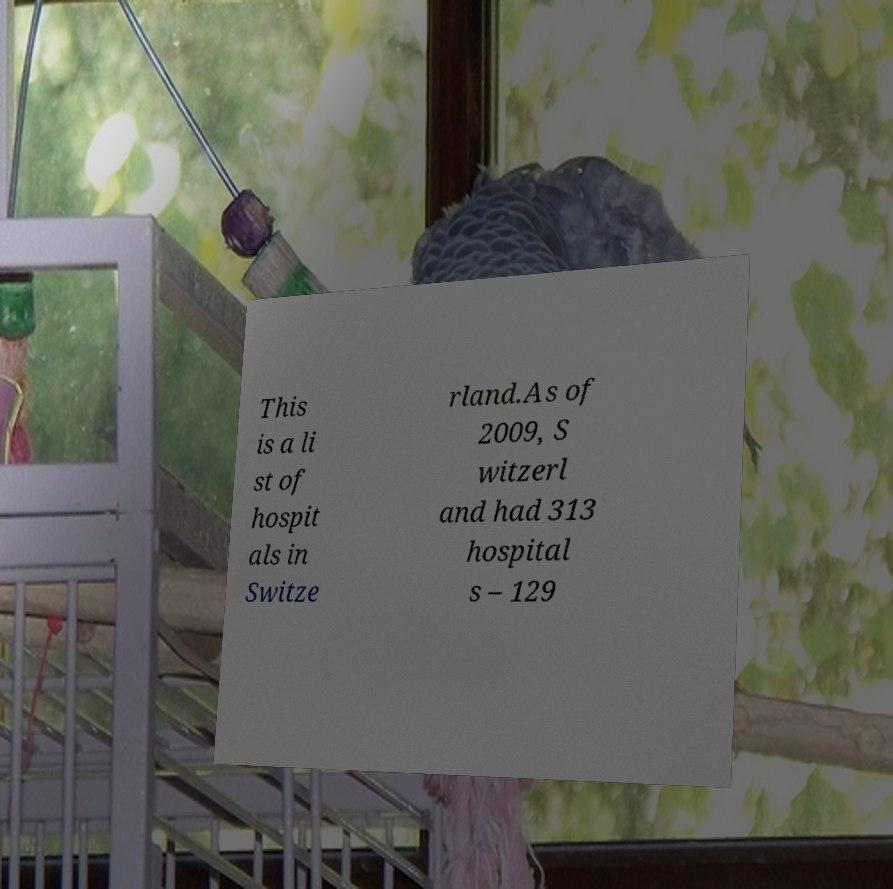For documentation purposes, I need the text within this image transcribed. Could you provide that? This is a li st of hospit als in Switze rland.As of 2009, S witzerl and had 313 hospital s – 129 